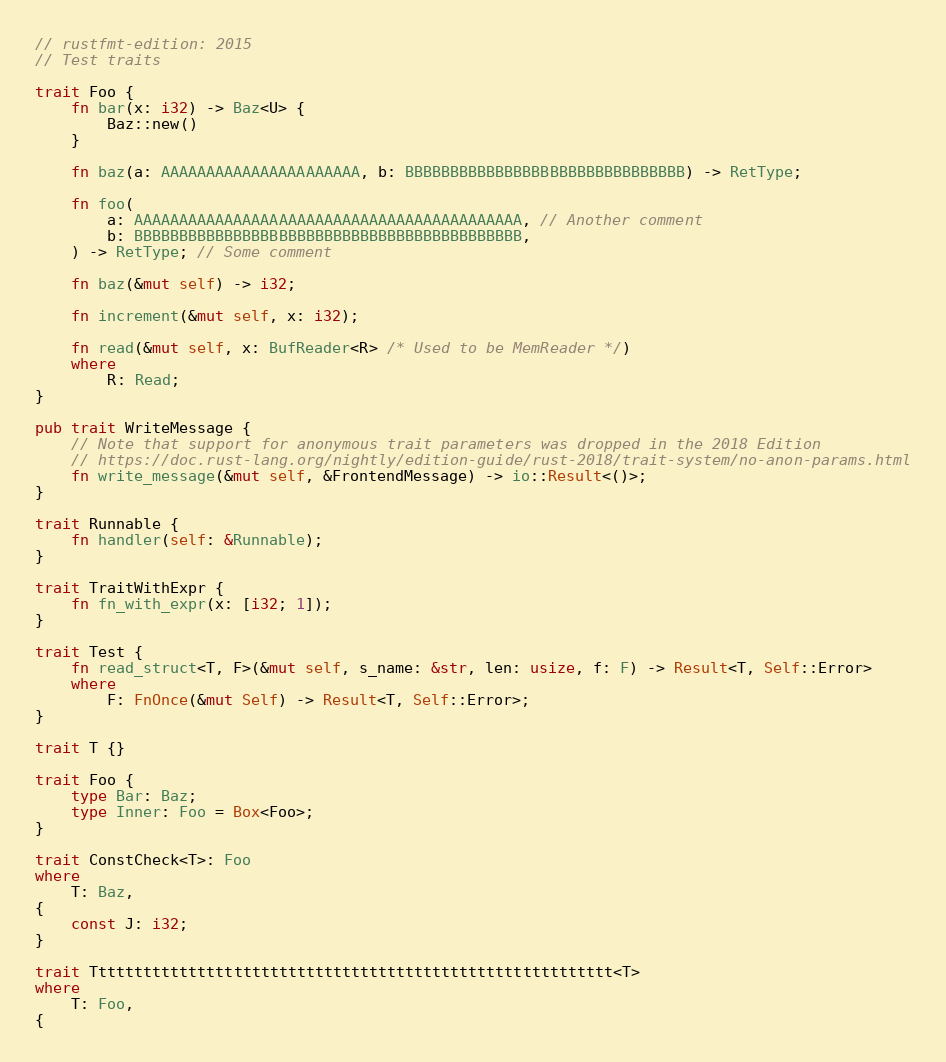<code> <loc_0><loc_0><loc_500><loc_500><_Rust_>// rustfmt-edition: 2015
// Test traits

trait Foo {
    fn bar(x: i32) -> Baz<U> {
        Baz::new()
    }

    fn baz(a: AAAAAAAAAAAAAAAAAAAAAA, b: BBBBBBBBBBBBBBBBBBBBBBBBBBBBBBB) -> RetType;

    fn foo(
        a: AAAAAAAAAAAAAAAAAAAAAAAAAAAAAAAAAAAAAAAAAAA, // Another comment
        b: BBBBBBBBBBBBBBBBBBBBBBBBBBBBBBBBBBBBBBBBBBB,
    ) -> RetType; // Some comment

    fn baz(&mut self) -> i32;

    fn increment(&mut self, x: i32);

    fn read(&mut self, x: BufReader<R> /* Used to be MemReader */)
    where
        R: Read;
}

pub trait WriteMessage {
    // Note that support for anonymous trait parameters was dropped in the 2018 Edition
    // https://doc.rust-lang.org/nightly/edition-guide/rust-2018/trait-system/no-anon-params.html
    fn write_message(&mut self, &FrontendMessage) -> io::Result<()>;
}

trait Runnable {
    fn handler(self: &Runnable);
}

trait TraitWithExpr {
    fn fn_with_expr(x: [i32; 1]);
}

trait Test {
    fn read_struct<T, F>(&mut self, s_name: &str, len: usize, f: F) -> Result<T, Self::Error>
    where
        F: FnOnce(&mut Self) -> Result<T, Self::Error>;
}

trait T {}

trait Foo {
    type Bar: Baz;
    type Inner: Foo = Box<Foo>;
}

trait ConstCheck<T>: Foo
where
    T: Baz,
{
    const J: i32;
}

trait Tttttttttttttttttttttttttttttttttttttttttttttttttttttttttt<T>
where
    T: Foo,
{</code> 